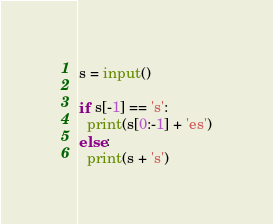Convert code to text. <code><loc_0><loc_0><loc_500><loc_500><_Python_>s = input()

if s[-1] == 's':
  print(s[0:-1] + 'es')
else:
  print(s + 's')
</code> 